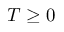<formula> <loc_0><loc_0><loc_500><loc_500>T \geq 0</formula> 